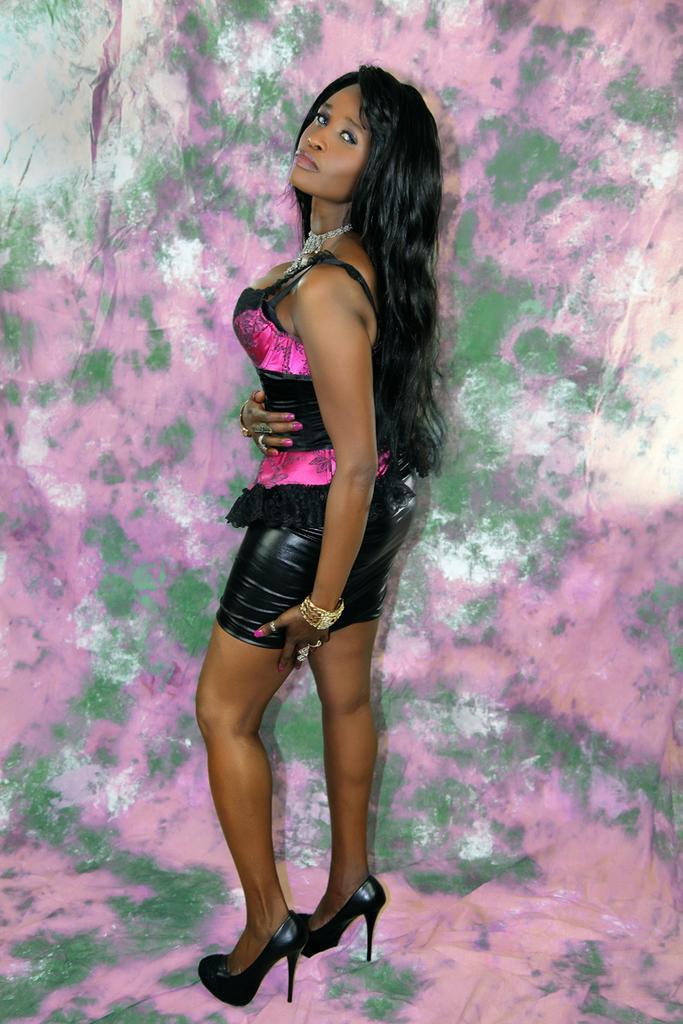Could you give a brief overview of what you see in this image? In this image we can see a person wearing black and pink color dress standing also wearing bangles and black color heels and at the background of the image there is pink and green color sheet. 